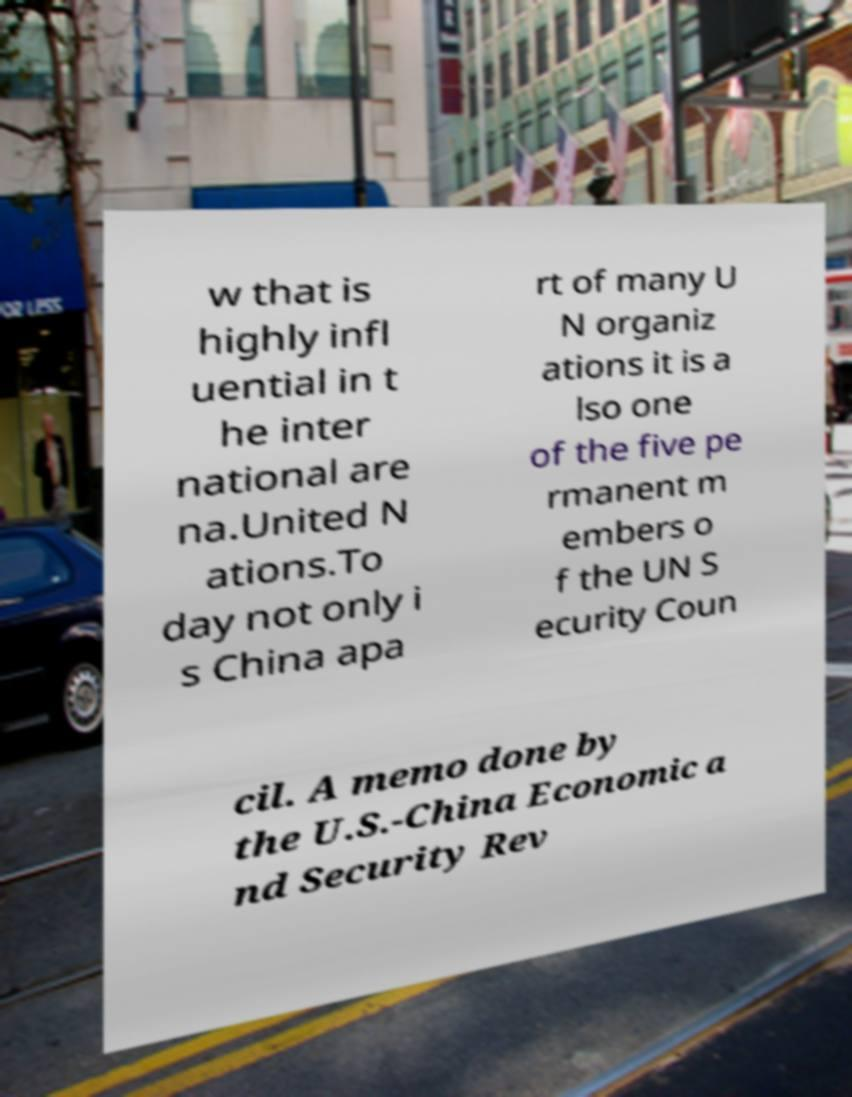For documentation purposes, I need the text within this image transcribed. Could you provide that? w that is highly infl uential in t he inter national are na.United N ations.To day not only i s China apa rt of many U N organiz ations it is a lso one of the five pe rmanent m embers o f the UN S ecurity Coun cil. A memo done by the U.S.-China Economic a nd Security Rev 